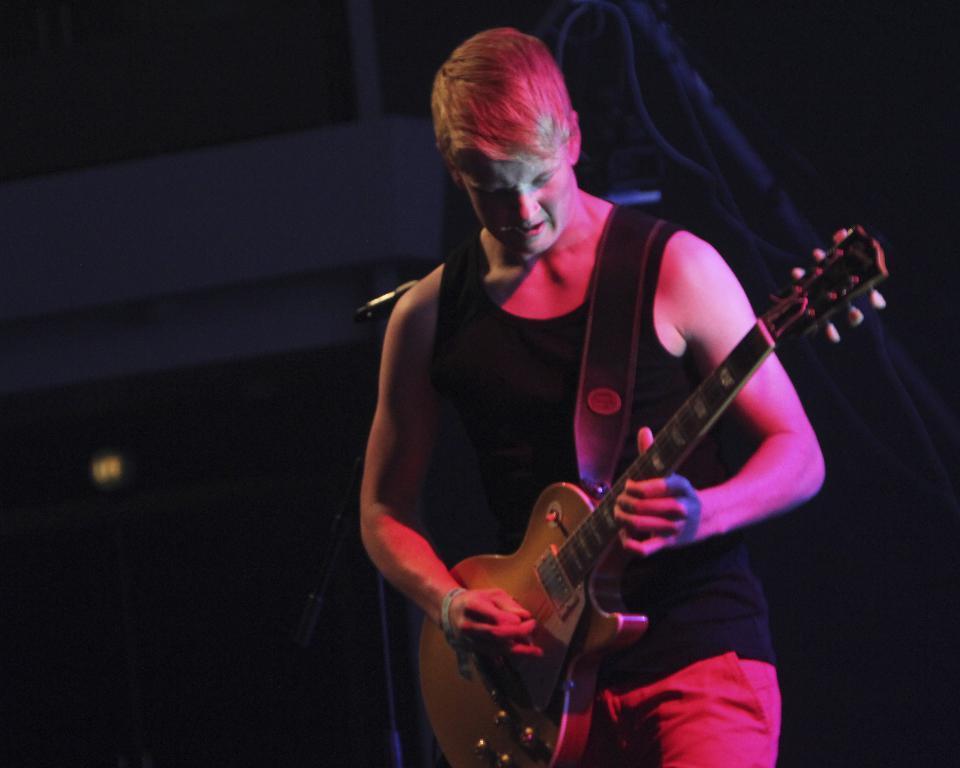Can you describe this image briefly? This is a picture of a man in black t shirt was holding a guitar to the left side of the man there is a microphone with stand. Behind the man there is a wall and some cables. 